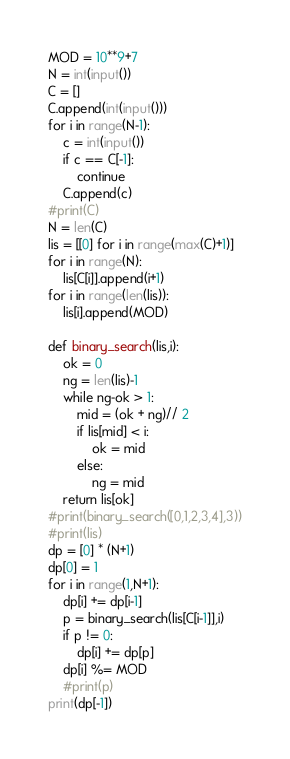<code> <loc_0><loc_0><loc_500><loc_500><_Python_>MOD = 10**9+7
N = int(input())
C = []
C.append(int(input()))
for i in range(N-1):
    c = int(input())
    if c == C[-1]:
        continue
    C.append(c)
#print(C)
N = len(C)
lis = [[0] for i in range(max(C)+1)]
for i in range(N):
    lis[C[i]].append(i+1)
for i in range(len(lis)):
    lis[i].append(MOD)

def binary_search(lis,i):
    ok = 0
    ng = len(lis)-1
    while ng-ok > 1:
        mid = (ok + ng)// 2
        if lis[mid] < i:
            ok = mid
        else:
            ng = mid
    return lis[ok]
#print(binary_search([0,1,2,3,4],3))
#print(lis)
dp = [0] * (N+1)
dp[0] = 1
for i in range(1,N+1):
    dp[i] += dp[i-1]
    p = binary_search(lis[C[i-1]],i)
    if p != 0:
        dp[i] += dp[p]
    dp[i] %= MOD
    #print(p)
print(dp[-1])
</code> 